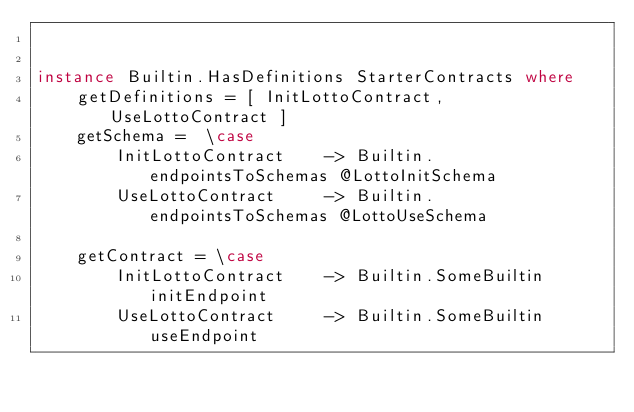Convert code to text. <code><loc_0><loc_0><loc_500><loc_500><_Haskell_> 

instance Builtin.HasDefinitions StarterContracts where
    getDefinitions = [ InitLottoContract, UseLottoContract ]
    getSchema =  \case
        InitLottoContract    -> Builtin.endpointsToSchemas @LottoInitSchema
        UseLottoContract     -> Builtin.endpointsToSchemas @LottoUseSchema   
   
    getContract = \case
        InitLottoContract    -> Builtin.SomeBuiltin initEndpoint
        UseLottoContract     -> Builtin.SomeBuiltin useEndpoint
     
</code> 